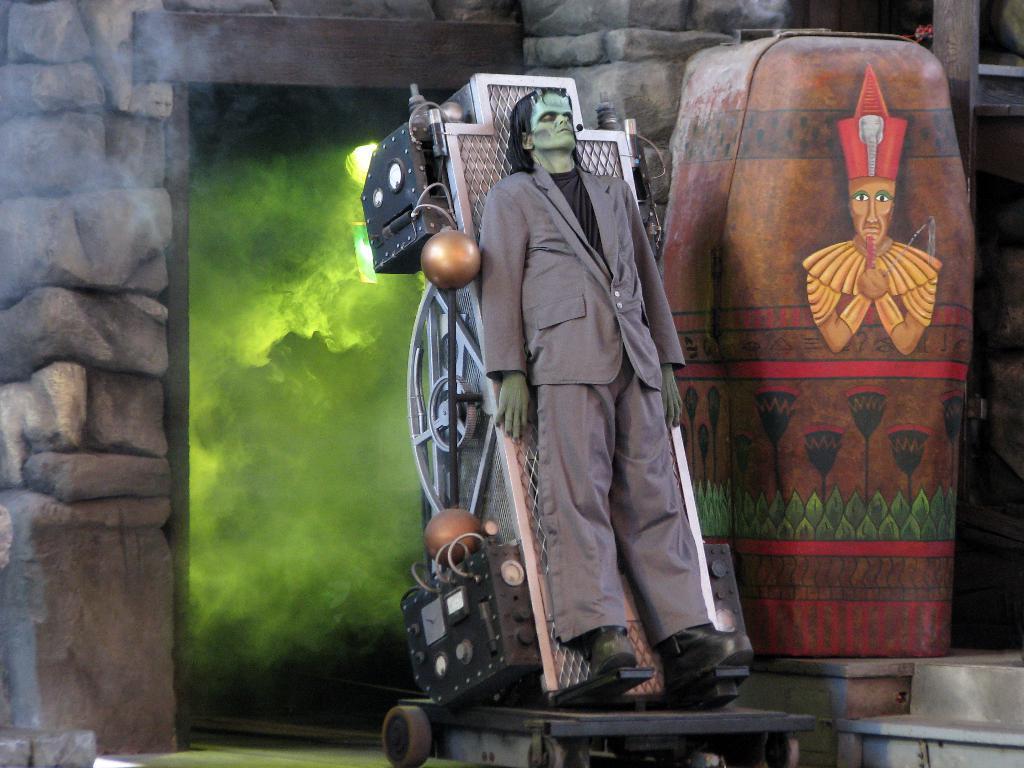Please provide a concise description of this image. In the center of this picture we can see a person as an object. On the right we can see the picture of a person on a brown color object and we can see there are some objects placed on the ground. In the background we can see the stone wall and the smoke. 